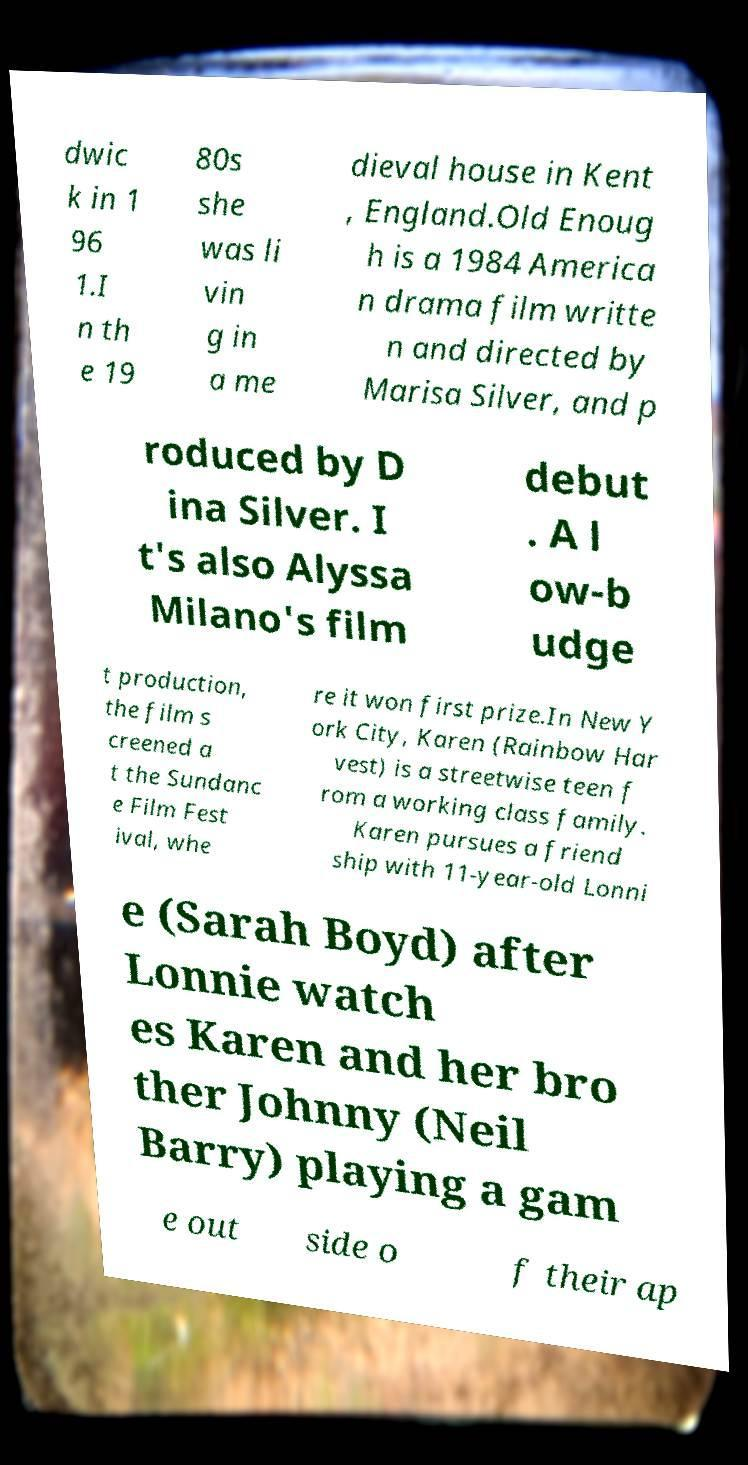I need the written content from this picture converted into text. Can you do that? dwic k in 1 96 1.I n th e 19 80s she was li vin g in a me dieval house in Kent , England.Old Enoug h is a 1984 America n drama film writte n and directed by Marisa Silver, and p roduced by D ina Silver. I t's also Alyssa Milano's film debut . A l ow-b udge t production, the film s creened a t the Sundanc e Film Fest ival, whe re it won first prize.In New Y ork City, Karen (Rainbow Har vest) is a streetwise teen f rom a working class family. Karen pursues a friend ship with 11-year-old Lonni e (Sarah Boyd) after Lonnie watch es Karen and her bro ther Johnny (Neil Barry) playing a gam e out side o f their ap 